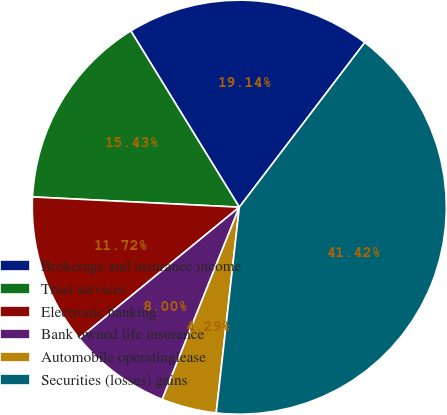<chart> <loc_0><loc_0><loc_500><loc_500><pie_chart><fcel>Brokerage and insurance income<fcel>Trust services<fcel>Electronic banking<fcel>Bank owned life insurance<fcel>Automobile operatinglease<fcel>Securities (losses) gains<nl><fcel>19.14%<fcel>15.43%<fcel>11.72%<fcel>8.0%<fcel>4.29%<fcel>41.42%<nl></chart> 